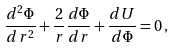Convert formula to latex. <formula><loc_0><loc_0><loc_500><loc_500>\frac { d ^ { 2 } \Phi } { d \, r ^ { 2 } } + \frac { 2 } { r } \frac { d \Phi } { d r } + \frac { d U } { d \Phi } = 0 \, ,</formula> 